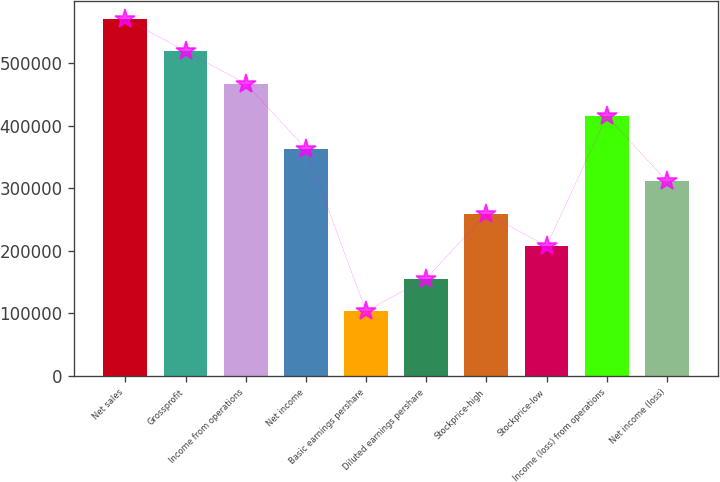<chart> <loc_0><loc_0><loc_500><loc_500><bar_chart><fcel>Net sales<fcel>Grossprofit<fcel>Income from operations<fcel>Net income<fcel>Basic earnings pershare<fcel>Diluted earnings pershare<fcel>Stockprice-high<fcel>Stockprice-low<fcel>Income (loss) from operations<fcel>Net income (loss)<nl><fcel>571258<fcel>519325<fcel>467393<fcel>363528<fcel>103865<fcel>155798<fcel>259663<fcel>207730<fcel>415460<fcel>311595<nl></chart> 